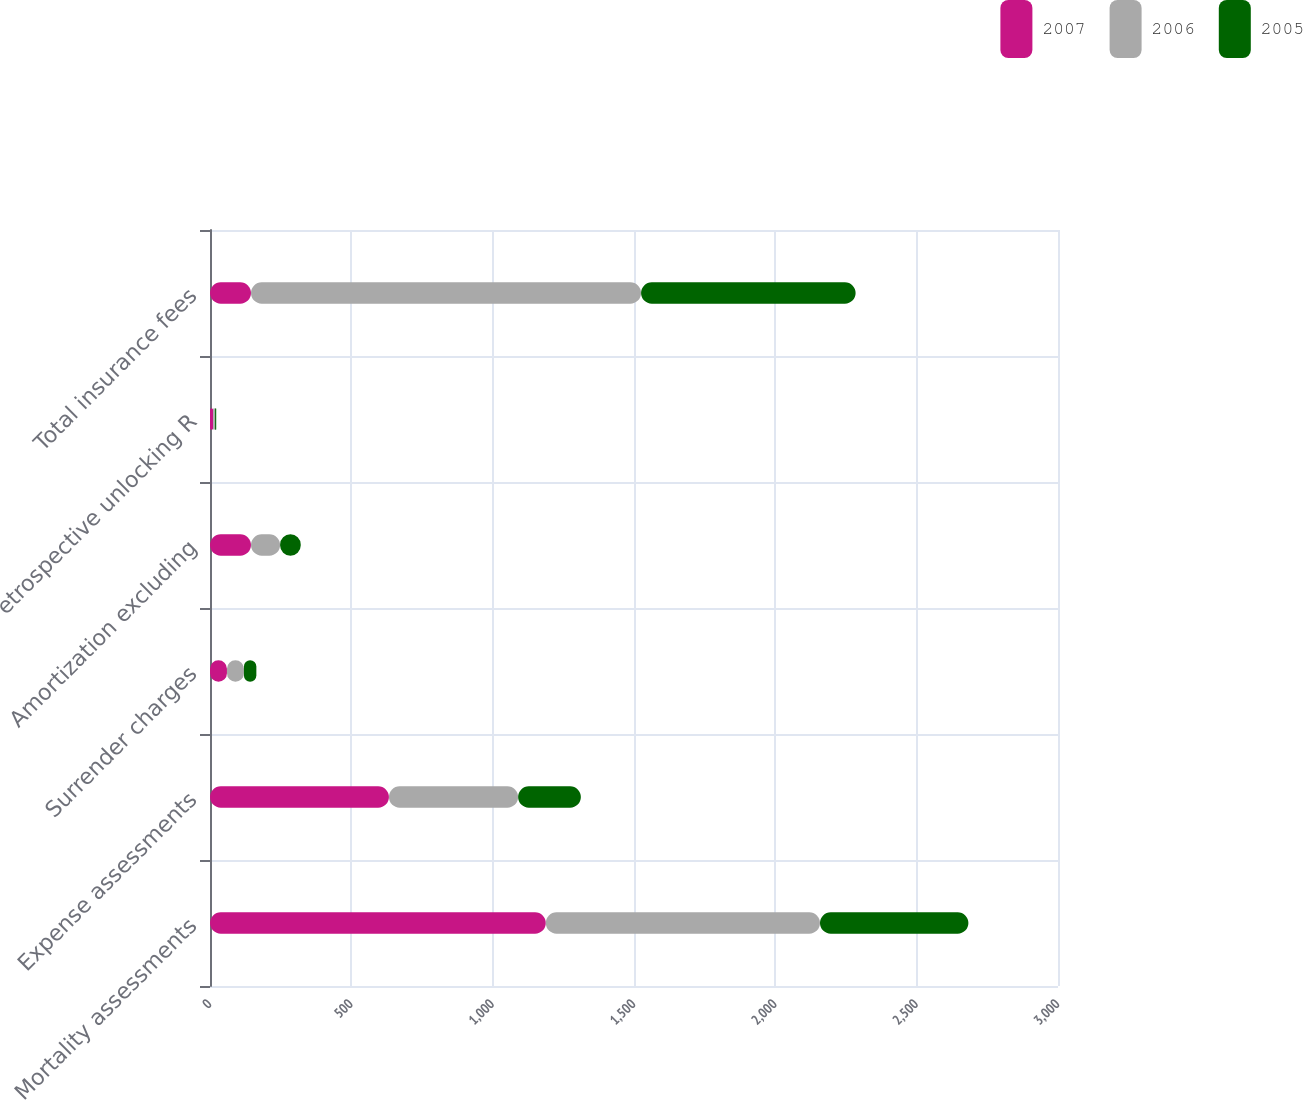<chart> <loc_0><loc_0><loc_500><loc_500><stacked_bar_chart><ecel><fcel>Mortality assessments<fcel>Expense assessments<fcel>Surrender charges<fcel>Amortization excluding<fcel>etrospective unlocking R<fcel>Total insurance fees<nl><fcel>2007<fcel>1188<fcel>633<fcel>60<fcel>145<fcel>11<fcel>145<nl><fcel>2006<fcel>970<fcel>457<fcel>60<fcel>103<fcel>7<fcel>1380<nl><fcel>2005<fcel>525<fcel>222<fcel>44<fcel>73<fcel>4<fcel>759<nl></chart> 